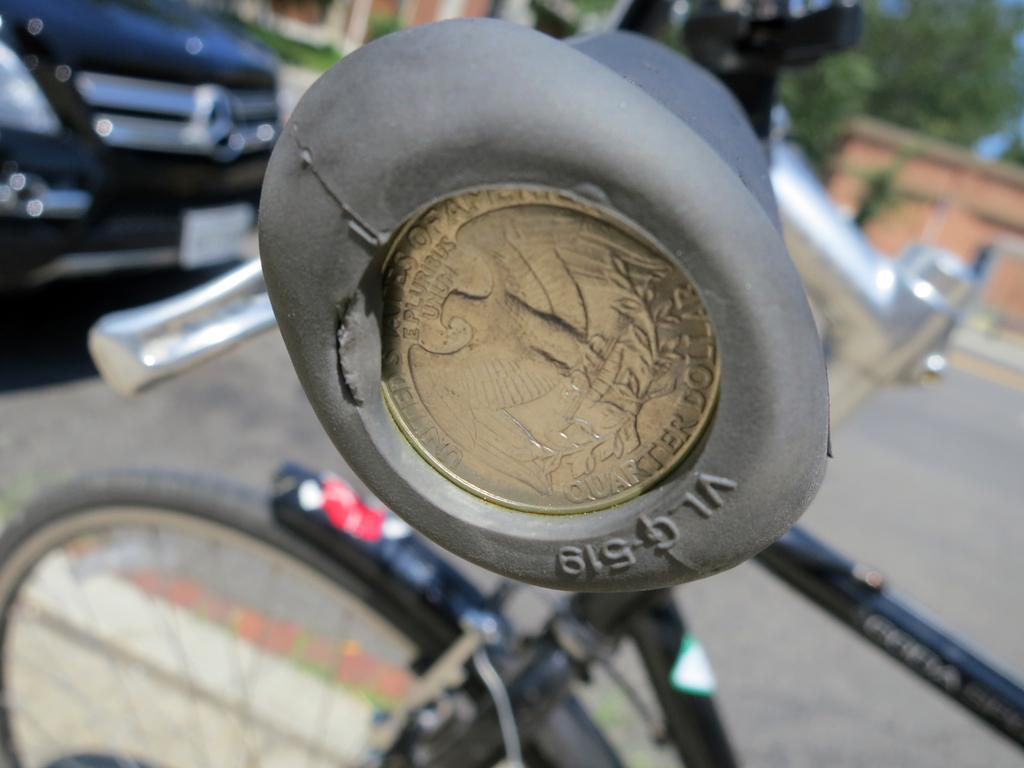What is the main object in the foreground of the image? There is a bicycle handle in the image. How would you describe the background of the image? The background of the image is blurred. What can be seen in the background of the image? There is a bicycle, a car, and trees visible in the background. What type of approval is being sought in the image? There is no indication in the image that approval is being sought; it features a bicycle handle and a blurred background with objects in the distance. 